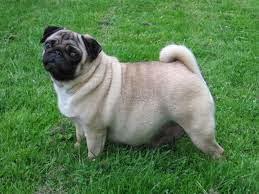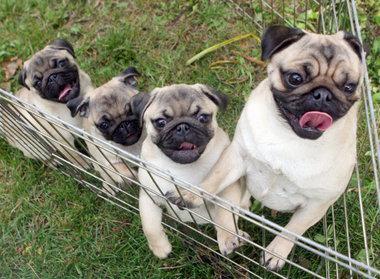The first image is the image on the left, the second image is the image on the right. Assess this claim about the two images: "The right image contains no more than one dog.". Correct or not? Answer yes or no. No. The first image is the image on the left, the second image is the image on the right. Evaluate the accuracy of this statement regarding the images: "Three buff-beige pugs are side-by-side on the grass in one image, and one dog standing and wearing a collar is in the other image.". Is it true? Answer yes or no. No. 